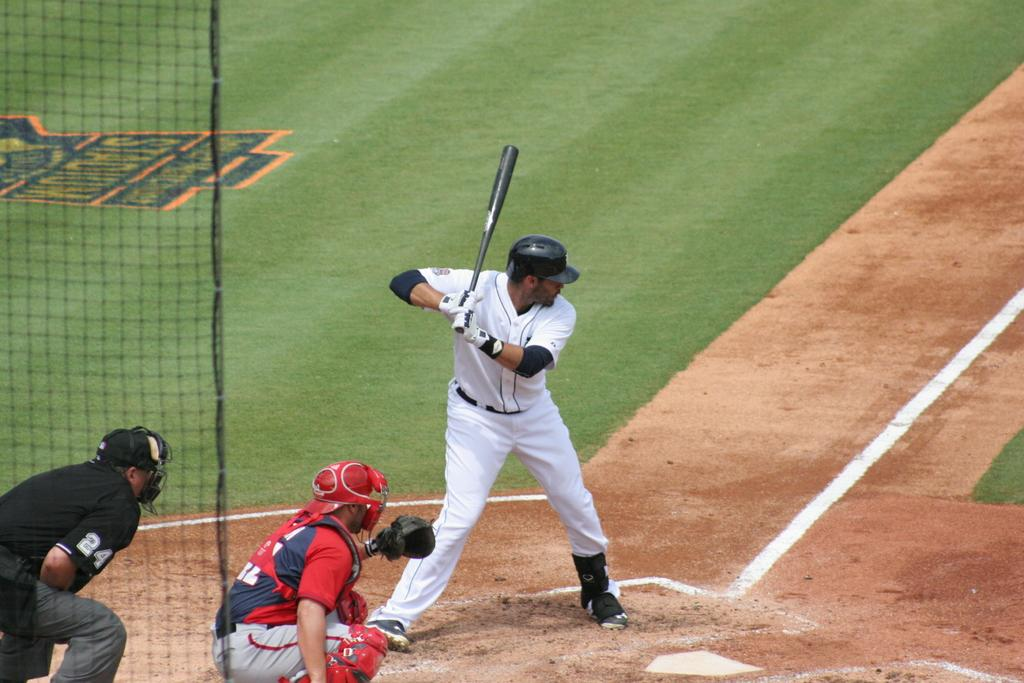<image>
Give a short and clear explanation of the subsequent image. a batter in front of an Umpire with the number 24 